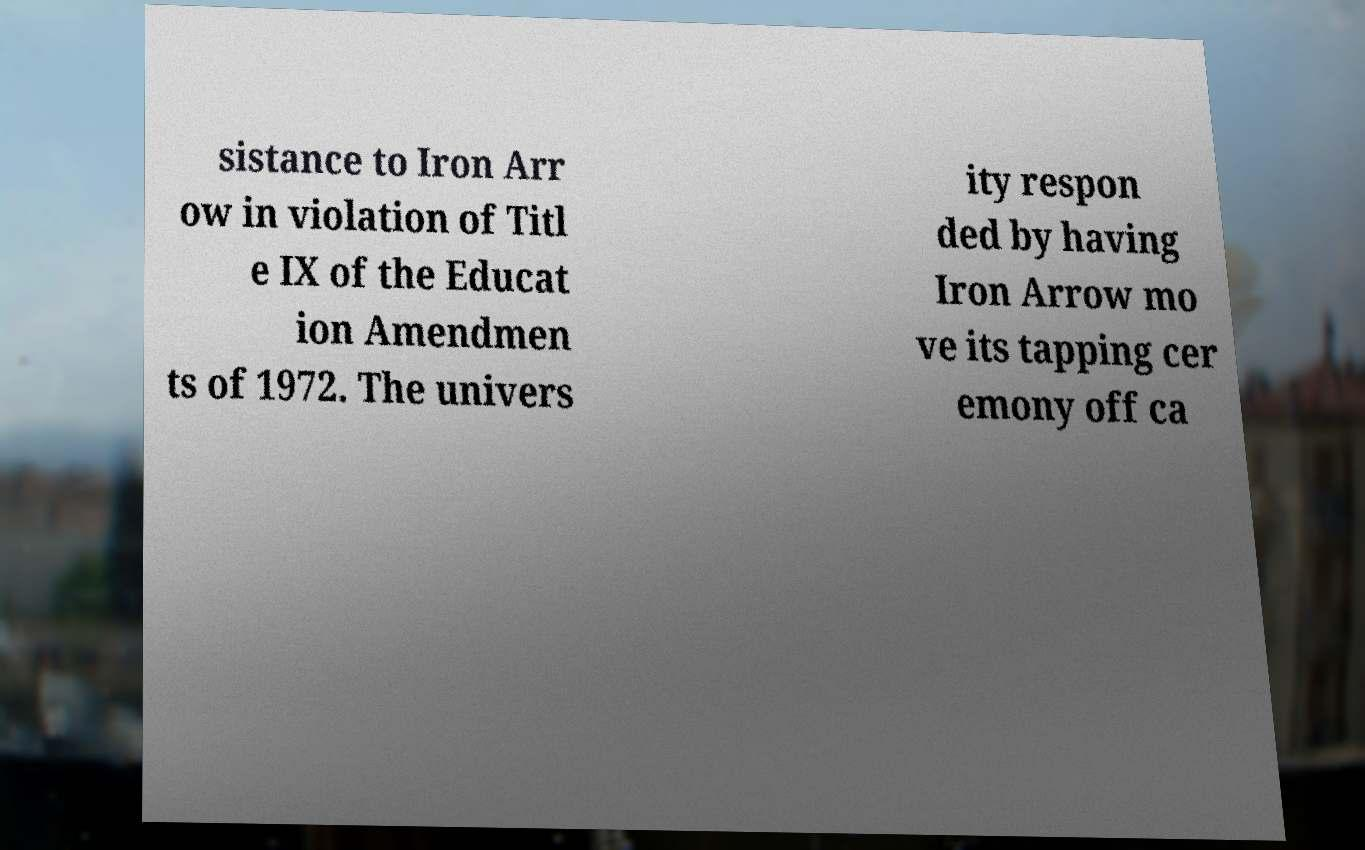For documentation purposes, I need the text within this image transcribed. Could you provide that? sistance to Iron Arr ow in violation of Titl e IX of the Educat ion Amendmen ts of 1972. The univers ity respon ded by having Iron Arrow mo ve its tapping cer emony off ca 